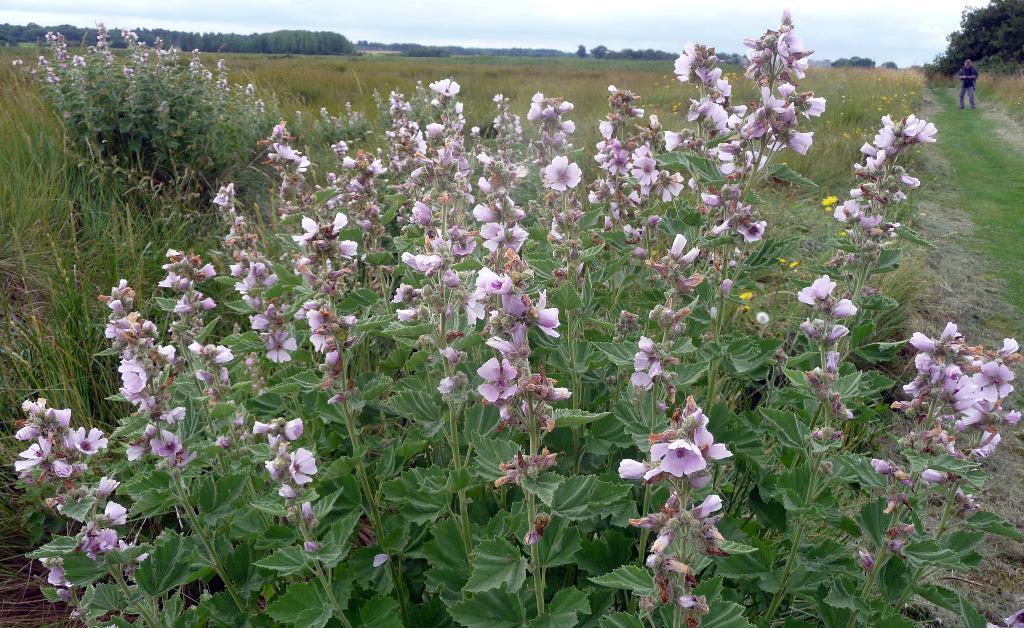Can you describe this image briefly? There are plants having flowers and green color leaves on the ground. In the background, there is a person standing on the ground, on which there is grass, there are trees and plants on the ground and there is sky. 